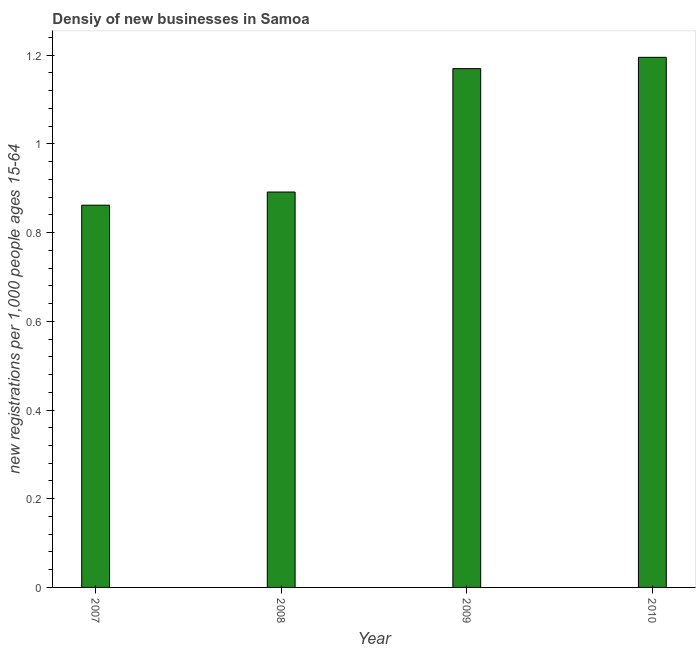Does the graph contain any zero values?
Provide a succinct answer. No. Does the graph contain grids?
Provide a short and direct response. No. What is the title of the graph?
Ensure brevity in your answer.  Densiy of new businesses in Samoa. What is the label or title of the Y-axis?
Keep it short and to the point. New registrations per 1,0 people ages 15-64. What is the density of new business in 2009?
Your answer should be very brief. 1.17. Across all years, what is the maximum density of new business?
Offer a very short reply. 1.2. Across all years, what is the minimum density of new business?
Your answer should be compact. 0.86. In which year was the density of new business maximum?
Keep it short and to the point. 2010. In which year was the density of new business minimum?
Provide a succinct answer. 2007. What is the sum of the density of new business?
Your response must be concise. 4.12. What is the difference between the density of new business in 2007 and 2010?
Ensure brevity in your answer.  -0.33. What is the median density of new business?
Ensure brevity in your answer.  1.03. Do a majority of the years between 2008 and 2007 (inclusive) have density of new business greater than 0.08 ?
Provide a succinct answer. No. What is the ratio of the density of new business in 2007 to that in 2009?
Provide a succinct answer. 0.74. Is the density of new business in 2007 less than that in 2010?
Make the answer very short. Yes. What is the difference between the highest and the second highest density of new business?
Provide a short and direct response. 0.03. What is the difference between the highest and the lowest density of new business?
Ensure brevity in your answer.  0.33. In how many years, is the density of new business greater than the average density of new business taken over all years?
Ensure brevity in your answer.  2. Are all the bars in the graph horizontal?
Your answer should be very brief. No. How many years are there in the graph?
Offer a terse response. 4. What is the difference between two consecutive major ticks on the Y-axis?
Provide a short and direct response. 0.2. What is the new registrations per 1,000 people ages 15-64 of 2007?
Offer a very short reply. 0.86. What is the new registrations per 1,000 people ages 15-64 of 2008?
Offer a terse response. 0.89. What is the new registrations per 1,000 people ages 15-64 in 2009?
Your answer should be compact. 1.17. What is the new registrations per 1,000 people ages 15-64 of 2010?
Offer a very short reply. 1.2. What is the difference between the new registrations per 1,000 people ages 15-64 in 2007 and 2008?
Your answer should be very brief. -0.03. What is the difference between the new registrations per 1,000 people ages 15-64 in 2007 and 2009?
Provide a short and direct response. -0.31. What is the difference between the new registrations per 1,000 people ages 15-64 in 2007 and 2010?
Provide a succinct answer. -0.33. What is the difference between the new registrations per 1,000 people ages 15-64 in 2008 and 2009?
Your response must be concise. -0.28. What is the difference between the new registrations per 1,000 people ages 15-64 in 2008 and 2010?
Ensure brevity in your answer.  -0.3. What is the difference between the new registrations per 1,000 people ages 15-64 in 2009 and 2010?
Make the answer very short. -0.03. What is the ratio of the new registrations per 1,000 people ages 15-64 in 2007 to that in 2008?
Ensure brevity in your answer.  0.97. What is the ratio of the new registrations per 1,000 people ages 15-64 in 2007 to that in 2009?
Provide a short and direct response. 0.74. What is the ratio of the new registrations per 1,000 people ages 15-64 in 2007 to that in 2010?
Give a very brief answer. 0.72. What is the ratio of the new registrations per 1,000 people ages 15-64 in 2008 to that in 2009?
Give a very brief answer. 0.76. What is the ratio of the new registrations per 1,000 people ages 15-64 in 2008 to that in 2010?
Provide a short and direct response. 0.75. What is the ratio of the new registrations per 1,000 people ages 15-64 in 2009 to that in 2010?
Provide a succinct answer. 0.98. 